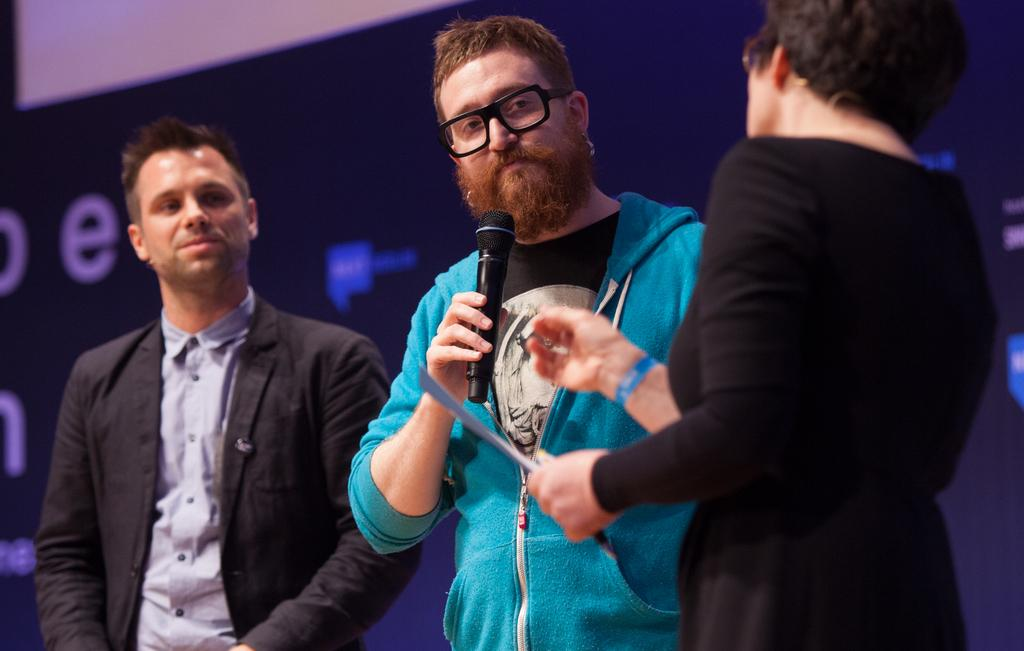How many people are in the image? There are three people in the image. What is the person in the middle doing? The person in the middle is holding a microphone. What else can be seen in the image besides the people? There is a screen visible in the image. What is the weight of the cats in the image? There are no cats present in the image, so their weight cannot be determined. 